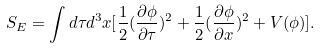Convert formula to latex. <formula><loc_0><loc_0><loc_500><loc_500>S _ { E } = \int d \tau d ^ { 3 } x [ \frac { 1 } { 2 } ( \frac { \partial { \phi } } { \partial { \tau } } ) ^ { 2 } + \frac { 1 } { 2 } ( \frac { \partial { \phi } } { \partial { x } } ) ^ { 2 } + V ( \phi ) ] .</formula> 